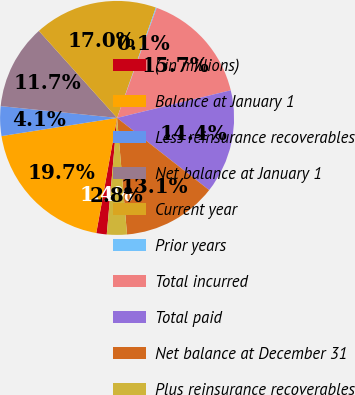Convert chart to OTSL. <chart><loc_0><loc_0><loc_500><loc_500><pie_chart><fcel>( in millions)<fcel>Balance at January 1<fcel>Less reinsurance recoverables<fcel>Net balance at January 1<fcel>Current year<fcel>Prior years<fcel>Total incurred<fcel>Total paid<fcel>Net balance at December 31<fcel>Plus reinsurance recoverables<nl><fcel>1.44%<fcel>19.67%<fcel>4.09%<fcel>11.74%<fcel>17.03%<fcel>0.12%<fcel>15.7%<fcel>14.38%<fcel>13.06%<fcel>2.76%<nl></chart> 